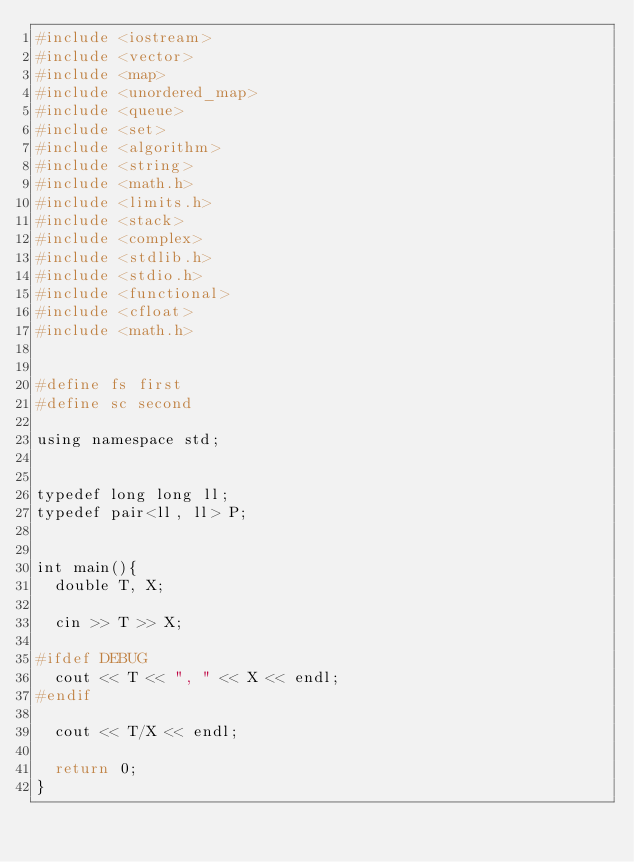<code> <loc_0><loc_0><loc_500><loc_500><_Ruby_>#include <iostream>
#include <vector>
#include <map>
#include <unordered_map>
#include <queue>
#include <set>
#include <algorithm>
#include <string>
#include <math.h>
#include <limits.h>
#include <stack>
#include <complex>
#include <stdlib.h>
#include <stdio.h>
#include <functional>
#include <cfloat>
#include <math.h>
     
     
#define fs first
#define sc second
     
using namespace std;
     
     
typedef long long ll;
typedef pair<ll, ll> P;
     
     
int main(){
  double T, X;

  cin >> T >> X;

#ifdef DEBUG
  cout << T << ", " << X << endl;
#endif

  cout << T/X << endl;
  
  return 0;
}
</code> 